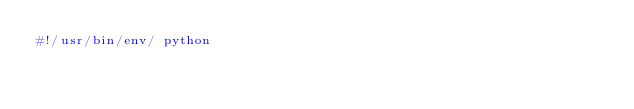Convert code to text. <code><loc_0><loc_0><loc_500><loc_500><_Python_>#!/usr/bin/env/ python
</code> 